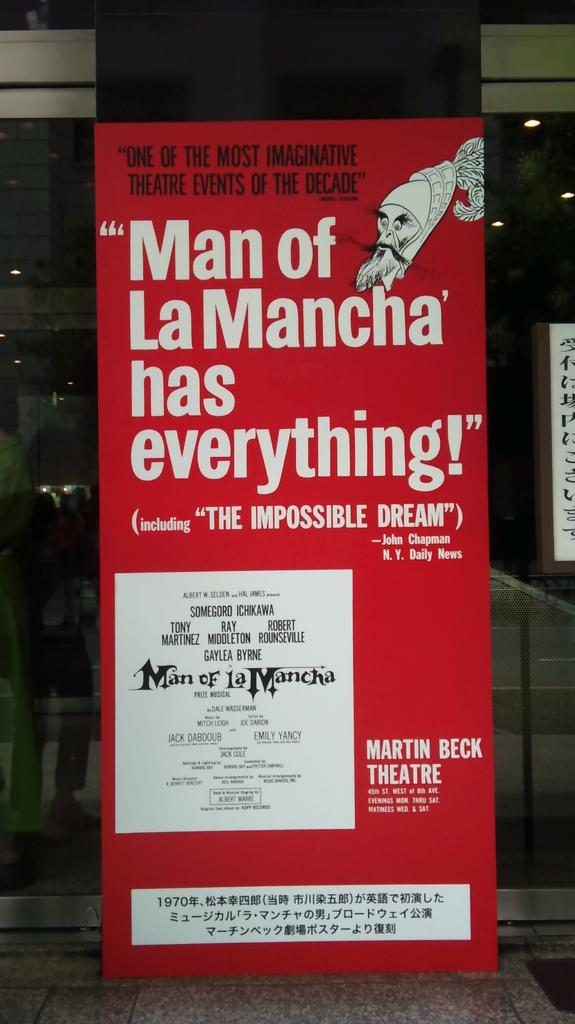<image>
Summarize the visual content of the image. A red poster for Man of La Mancha has white text. 